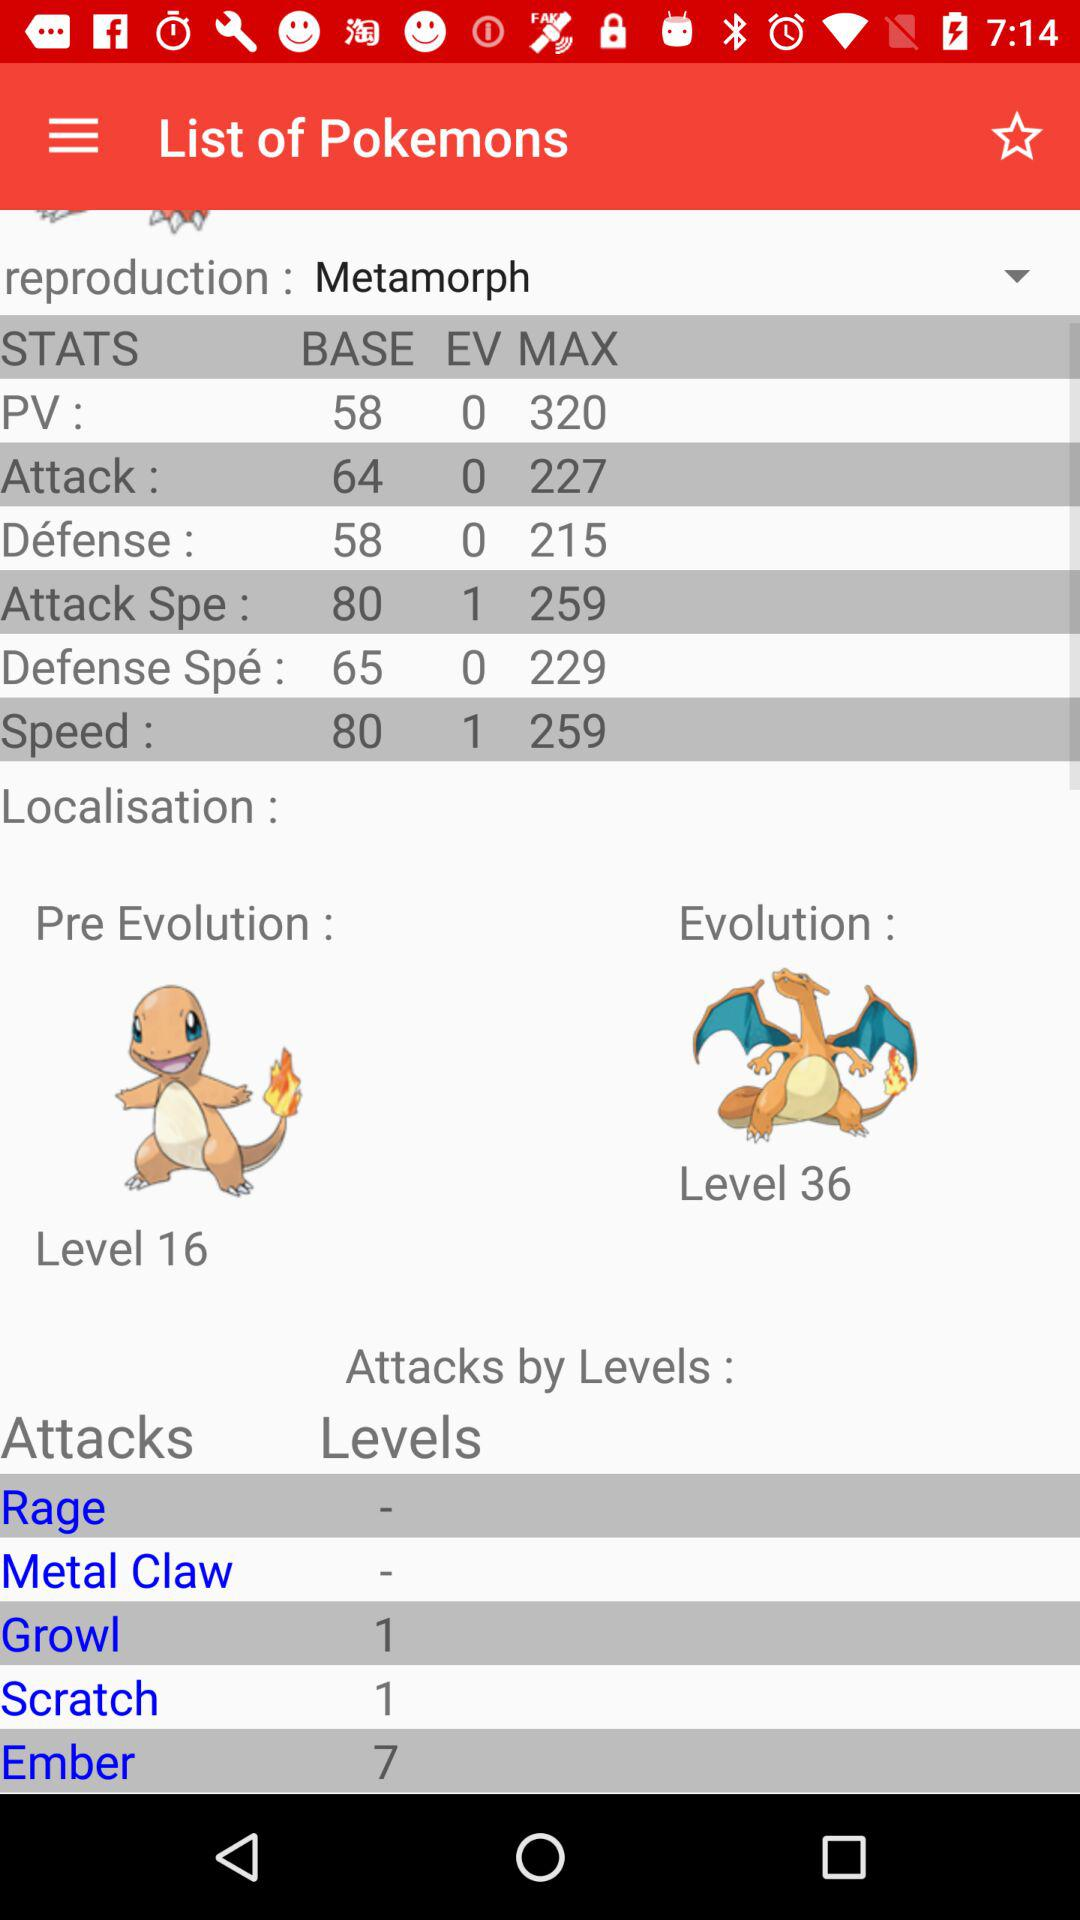What is the level of the "Growl" attack? The level of the "Growl" attack is 1. 